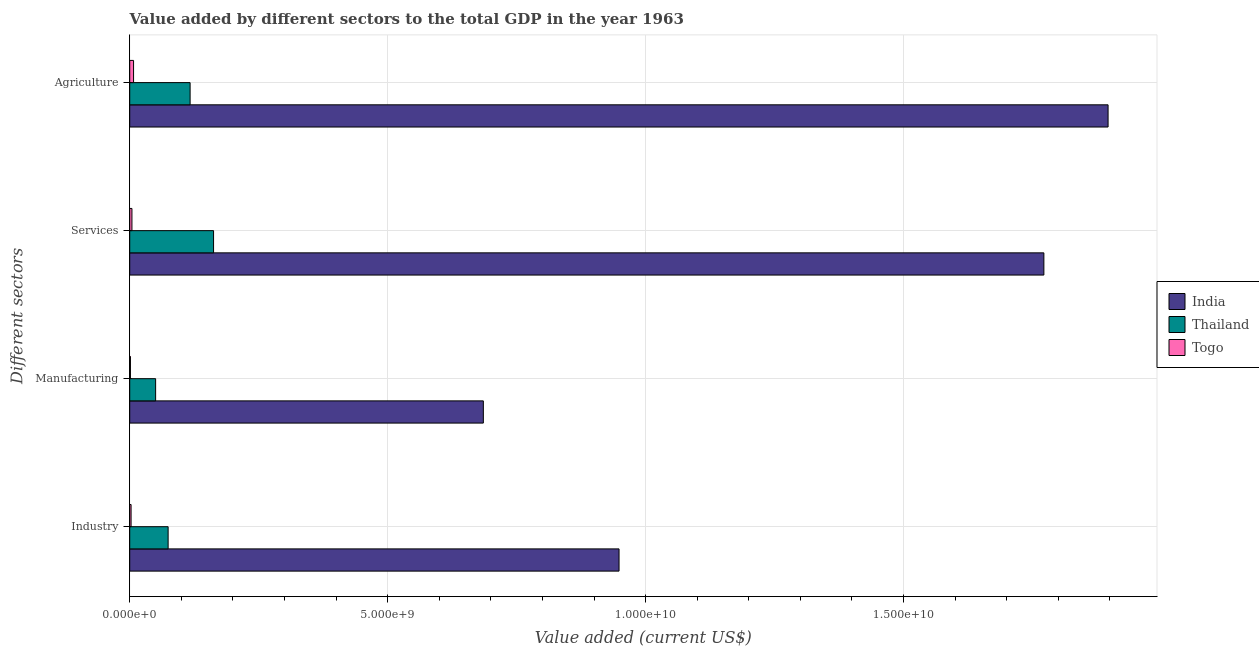How many groups of bars are there?
Give a very brief answer. 4. Are the number of bars per tick equal to the number of legend labels?
Offer a very short reply. Yes. How many bars are there on the 2nd tick from the top?
Offer a terse response. 3. What is the label of the 2nd group of bars from the top?
Provide a succinct answer. Services. What is the value added by manufacturing sector in Togo?
Provide a succinct answer. 1.39e+07. Across all countries, what is the maximum value added by services sector?
Provide a short and direct response. 1.77e+1. Across all countries, what is the minimum value added by manufacturing sector?
Provide a short and direct response. 1.39e+07. In which country was the value added by services sector maximum?
Ensure brevity in your answer.  India. In which country was the value added by services sector minimum?
Keep it short and to the point. Togo. What is the total value added by industrial sector in the graph?
Keep it short and to the point. 1.03e+1. What is the difference between the value added by services sector in Togo and that in Thailand?
Give a very brief answer. -1.58e+09. What is the difference between the value added by industrial sector in Thailand and the value added by services sector in Togo?
Give a very brief answer. 7.02e+08. What is the average value added by agricultural sector per country?
Your response must be concise. 6.74e+09. What is the difference between the value added by industrial sector and value added by manufacturing sector in India?
Your response must be concise. 2.63e+09. In how many countries, is the value added by manufacturing sector greater than 16000000000 US$?
Offer a very short reply. 0. What is the ratio of the value added by industrial sector in Togo to that in Thailand?
Make the answer very short. 0.04. Is the value added by services sector in Thailand less than that in Togo?
Ensure brevity in your answer.  No. What is the difference between the highest and the second highest value added by services sector?
Provide a succinct answer. 1.61e+1. What is the difference between the highest and the lowest value added by manufacturing sector?
Offer a terse response. 6.84e+09. Is the sum of the value added by manufacturing sector in India and Togo greater than the maximum value added by services sector across all countries?
Your answer should be compact. No. Is it the case that in every country, the sum of the value added by services sector and value added by manufacturing sector is greater than the sum of value added by agricultural sector and value added by industrial sector?
Provide a short and direct response. No. What does the 2nd bar from the top in Agriculture represents?
Keep it short and to the point. Thailand. What does the 1st bar from the bottom in Manufacturing represents?
Offer a very short reply. India. How many bars are there?
Offer a very short reply. 12. Are the values on the major ticks of X-axis written in scientific E-notation?
Your answer should be compact. Yes. Does the graph contain any zero values?
Provide a succinct answer. No. How are the legend labels stacked?
Ensure brevity in your answer.  Vertical. What is the title of the graph?
Make the answer very short. Value added by different sectors to the total GDP in the year 1963. What is the label or title of the X-axis?
Provide a succinct answer. Value added (current US$). What is the label or title of the Y-axis?
Offer a very short reply. Different sectors. What is the Value added (current US$) in India in Industry?
Offer a very short reply. 9.49e+09. What is the Value added (current US$) of Thailand in Industry?
Your answer should be compact. 7.44e+08. What is the Value added (current US$) in Togo in Industry?
Give a very brief answer. 2.61e+07. What is the Value added (current US$) of India in Manufacturing?
Your answer should be very brief. 6.85e+09. What is the Value added (current US$) of Thailand in Manufacturing?
Give a very brief answer. 5.02e+08. What is the Value added (current US$) in Togo in Manufacturing?
Provide a succinct answer. 1.39e+07. What is the Value added (current US$) in India in Services?
Offer a very short reply. 1.77e+1. What is the Value added (current US$) of Thailand in Services?
Ensure brevity in your answer.  1.63e+09. What is the Value added (current US$) of Togo in Services?
Keep it short and to the point. 4.29e+07. What is the Value added (current US$) in India in Agriculture?
Provide a succinct answer. 1.90e+1. What is the Value added (current US$) in Thailand in Agriculture?
Offer a terse response. 1.17e+09. What is the Value added (current US$) of Togo in Agriculture?
Your response must be concise. 7.43e+07. Across all Different sectors, what is the maximum Value added (current US$) of India?
Your answer should be very brief. 1.90e+1. Across all Different sectors, what is the maximum Value added (current US$) of Thailand?
Ensure brevity in your answer.  1.63e+09. Across all Different sectors, what is the maximum Value added (current US$) of Togo?
Your response must be concise. 7.43e+07. Across all Different sectors, what is the minimum Value added (current US$) in India?
Provide a short and direct response. 6.85e+09. Across all Different sectors, what is the minimum Value added (current US$) in Thailand?
Your response must be concise. 5.02e+08. Across all Different sectors, what is the minimum Value added (current US$) of Togo?
Your answer should be very brief. 1.39e+07. What is the total Value added (current US$) of India in the graph?
Your answer should be compact. 5.30e+1. What is the total Value added (current US$) of Thailand in the graph?
Make the answer very short. 4.04e+09. What is the total Value added (current US$) in Togo in the graph?
Provide a succinct answer. 1.57e+08. What is the difference between the Value added (current US$) in India in Industry and that in Manufacturing?
Your answer should be compact. 2.63e+09. What is the difference between the Value added (current US$) of Thailand in Industry and that in Manufacturing?
Ensure brevity in your answer.  2.42e+08. What is the difference between the Value added (current US$) of Togo in Industry and that in Manufacturing?
Make the answer very short. 1.22e+07. What is the difference between the Value added (current US$) of India in Industry and that in Services?
Keep it short and to the point. -8.24e+09. What is the difference between the Value added (current US$) in Thailand in Industry and that in Services?
Provide a short and direct response. -8.81e+08. What is the difference between the Value added (current US$) of Togo in Industry and that in Services?
Offer a very short reply. -1.67e+07. What is the difference between the Value added (current US$) in India in Industry and that in Agriculture?
Your answer should be compact. -9.48e+09. What is the difference between the Value added (current US$) of Thailand in Industry and that in Agriculture?
Ensure brevity in your answer.  -4.26e+08. What is the difference between the Value added (current US$) of Togo in Industry and that in Agriculture?
Ensure brevity in your answer.  -4.82e+07. What is the difference between the Value added (current US$) in India in Manufacturing and that in Services?
Your answer should be very brief. -1.09e+1. What is the difference between the Value added (current US$) in Thailand in Manufacturing and that in Services?
Offer a terse response. -1.12e+09. What is the difference between the Value added (current US$) of Togo in Manufacturing and that in Services?
Keep it short and to the point. -2.90e+07. What is the difference between the Value added (current US$) in India in Manufacturing and that in Agriculture?
Your answer should be compact. -1.21e+1. What is the difference between the Value added (current US$) in Thailand in Manufacturing and that in Agriculture?
Keep it short and to the point. -6.69e+08. What is the difference between the Value added (current US$) in Togo in Manufacturing and that in Agriculture?
Provide a short and direct response. -6.04e+07. What is the difference between the Value added (current US$) of India in Services and that in Agriculture?
Make the answer very short. -1.24e+09. What is the difference between the Value added (current US$) in Thailand in Services and that in Agriculture?
Give a very brief answer. 4.55e+08. What is the difference between the Value added (current US$) in Togo in Services and that in Agriculture?
Your answer should be compact. -3.14e+07. What is the difference between the Value added (current US$) in India in Industry and the Value added (current US$) in Thailand in Manufacturing?
Make the answer very short. 8.98e+09. What is the difference between the Value added (current US$) in India in Industry and the Value added (current US$) in Togo in Manufacturing?
Your response must be concise. 9.47e+09. What is the difference between the Value added (current US$) of Thailand in Industry and the Value added (current US$) of Togo in Manufacturing?
Your response must be concise. 7.31e+08. What is the difference between the Value added (current US$) of India in Industry and the Value added (current US$) of Thailand in Services?
Ensure brevity in your answer.  7.86e+09. What is the difference between the Value added (current US$) in India in Industry and the Value added (current US$) in Togo in Services?
Ensure brevity in your answer.  9.44e+09. What is the difference between the Value added (current US$) of Thailand in Industry and the Value added (current US$) of Togo in Services?
Offer a very short reply. 7.02e+08. What is the difference between the Value added (current US$) of India in Industry and the Value added (current US$) of Thailand in Agriculture?
Provide a succinct answer. 8.31e+09. What is the difference between the Value added (current US$) of India in Industry and the Value added (current US$) of Togo in Agriculture?
Offer a very short reply. 9.41e+09. What is the difference between the Value added (current US$) of Thailand in Industry and the Value added (current US$) of Togo in Agriculture?
Your response must be concise. 6.70e+08. What is the difference between the Value added (current US$) in India in Manufacturing and the Value added (current US$) in Thailand in Services?
Your answer should be compact. 5.23e+09. What is the difference between the Value added (current US$) of India in Manufacturing and the Value added (current US$) of Togo in Services?
Provide a succinct answer. 6.81e+09. What is the difference between the Value added (current US$) in Thailand in Manufacturing and the Value added (current US$) in Togo in Services?
Offer a terse response. 4.59e+08. What is the difference between the Value added (current US$) in India in Manufacturing and the Value added (current US$) in Thailand in Agriculture?
Provide a short and direct response. 5.68e+09. What is the difference between the Value added (current US$) of India in Manufacturing and the Value added (current US$) of Togo in Agriculture?
Your answer should be very brief. 6.78e+09. What is the difference between the Value added (current US$) of Thailand in Manufacturing and the Value added (current US$) of Togo in Agriculture?
Make the answer very short. 4.28e+08. What is the difference between the Value added (current US$) of India in Services and the Value added (current US$) of Thailand in Agriculture?
Keep it short and to the point. 1.66e+1. What is the difference between the Value added (current US$) in India in Services and the Value added (current US$) in Togo in Agriculture?
Provide a short and direct response. 1.76e+1. What is the difference between the Value added (current US$) of Thailand in Services and the Value added (current US$) of Togo in Agriculture?
Your response must be concise. 1.55e+09. What is the average Value added (current US$) of India per Different sectors?
Offer a terse response. 1.33e+1. What is the average Value added (current US$) in Thailand per Different sectors?
Ensure brevity in your answer.  1.01e+09. What is the average Value added (current US$) in Togo per Different sectors?
Keep it short and to the point. 3.93e+07. What is the difference between the Value added (current US$) of India and Value added (current US$) of Thailand in Industry?
Provide a succinct answer. 8.74e+09. What is the difference between the Value added (current US$) in India and Value added (current US$) in Togo in Industry?
Provide a succinct answer. 9.46e+09. What is the difference between the Value added (current US$) in Thailand and Value added (current US$) in Togo in Industry?
Ensure brevity in your answer.  7.18e+08. What is the difference between the Value added (current US$) of India and Value added (current US$) of Thailand in Manufacturing?
Your response must be concise. 6.35e+09. What is the difference between the Value added (current US$) of India and Value added (current US$) of Togo in Manufacturing?
Offer a very short reply. 6.84e+09. What is the difference between the Value added (current US$) of Thailand and Value added (current US$) of Togo in Manufacturing?
Provide a succinct answer. 4.88e+08. What is the difference between the Value added (current US$) in India and Value added (current US$) in Thailand in Services?
Provide a succinct answer. 1.61e+1. What is the difference between the Value added (current US$) in India and Value added (current US$) in Togo in Services?
Your answer should be compact. 1.77e+1. What is the difference between the Value added (current US$) in Thailand and Value added (current US$) in Togo in Services?
Your answer should be very brief. 1.58e+09. What is the difference between the Value added (current US$) of India and Value added (current US$) of Thailand in Agriculture?
Offer a terse response. 1.78e+1. What is the difference between the Value added (current US$) of India and Value added (current US$) of Togo in Agriculture?
Ensure brevity in your answer.  1.89e+1. What is the difference between the Value added (current US$) in Thailand and Value added (current US$) in Togo in Agriculture?
Provide a succinct answer. 1.10e+09. What is the ratio of the Value added (current US$) of India in Industry to that in Manufacturing?
Your response must be concise. 1.38. What is the ratio of the Value added (current US$) in Thailand in Industry to that in Manufacturing?
Your response must be concise. 1.48. What is the ratio of the Value added (current US$) of Togo in Industry to that in Manufacturing?
Ensure brevity in your answer.  1.88. What is the ratio of the Value added (current US$) in India in Industry to that in Services?
Your response must be concise. 0.54. What is the ratio of the Value added (current US$) in Thailand in Industry to that in Services?
Offer a terse response. 0.46. What is the ratio of the Value added (current US$) of Togo in Industry to that in Services?
Provide a short and direct response. 0.61. What is the ratio of the Value added (current US$) of India in Industry to that in Agriculture?
Ensure brevity in your answer.  0.5. What is the ratio of the Value added (current US$) in Thailand in Industry to that in Agriculture?
Give a very brief answer. 0.64. What is the ratio of the Value added (current US$) in Togo in Industry to that in Agriculture?
Your answer should be compact. 0.35. What is the ratio of the Value added (current US$) of India in Manufacturing to that in Services?
Provide a succinct answer. 0.39. What is the ratio of the Value added (current US$) in Thailand in Manufacturing to that in Services?
Your answer should be compact. 0.31. What is the ratio of the Value added (current US$) of Togo in Manufacturing to that in Services?
Your answer should be compact. 0.32. What is the ratio of the Value added (current US$) of India in Manufacturing to that in Agriculture?
Give a very brief answer. 0.36. What is the ratio of the Value added (current US$) in Thailand in Manufacturing to that in Agriculture?
Your response must be concise. 0.43. What is the ratio of the Value added (current US$) of Togo in Manufacturing to that in Agriculture?
Provide a succinct answer. 0.19. What is the ratio of the Value added (current US$) of India in Services to that in Agriculture?
Keep it short and to the point. 0.93. What is the ratio of the Value added (current US$) in Thailand in Services to that in Agriculture?
Offer a terse response. 1.39. What is the ratio of the Value added (current US$) of Togo in Services to that in Agriculture?
Your response must be concise. 0.58. What is the difference between the highest and the second highest Value added (current US$) of India?
Your answer should be very brief. 1.24e+09. What is the difference between the highest and the second highest Value added (current US$) of Thailand?
Your answer should be compact. 4.55e+08. What is the difference between the highest and the second highest Value added (current US$) of Togo?
Offer a terse response. 3.14e+07. What is the difference between the highest and the lowest Value added (current US$) in India?
Your answer should be very brief. 1.21e+1. What is the difference between the highest and the lowest Value added (current US$) in Thailand?
Offer a very short reply. 1.12e+09. What is the difference between the highest and the lowest Value added (current US$) of Togo?
Make the answer very short. 6.04e+07. 